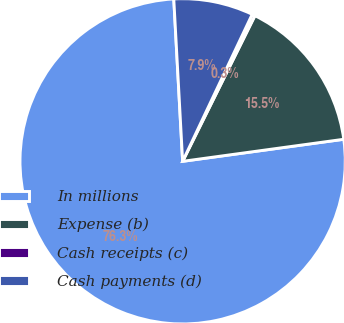<chart> <loc_0><loc_0><loc_500><loc_500><pie_chart><fcel>In millions<fcel>Expense (b)<fcel>Cash receipts (c)<fcel>Cash payments (d)<nl><fcel>76.29%<fcel>15.5%<fcel>0.3%<fcel>7.9%<nl></chart> 